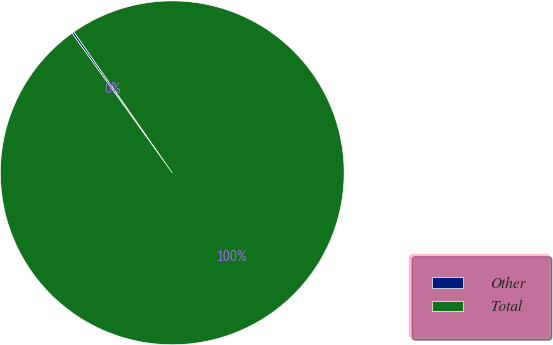Convert chart. <chart><loc_0><loc_0><loc_500><loc_500><pie_chart><fcel>Other<fcel>Total<nl><fcel>0.21%<fcel>99.79%<nl></chart> 